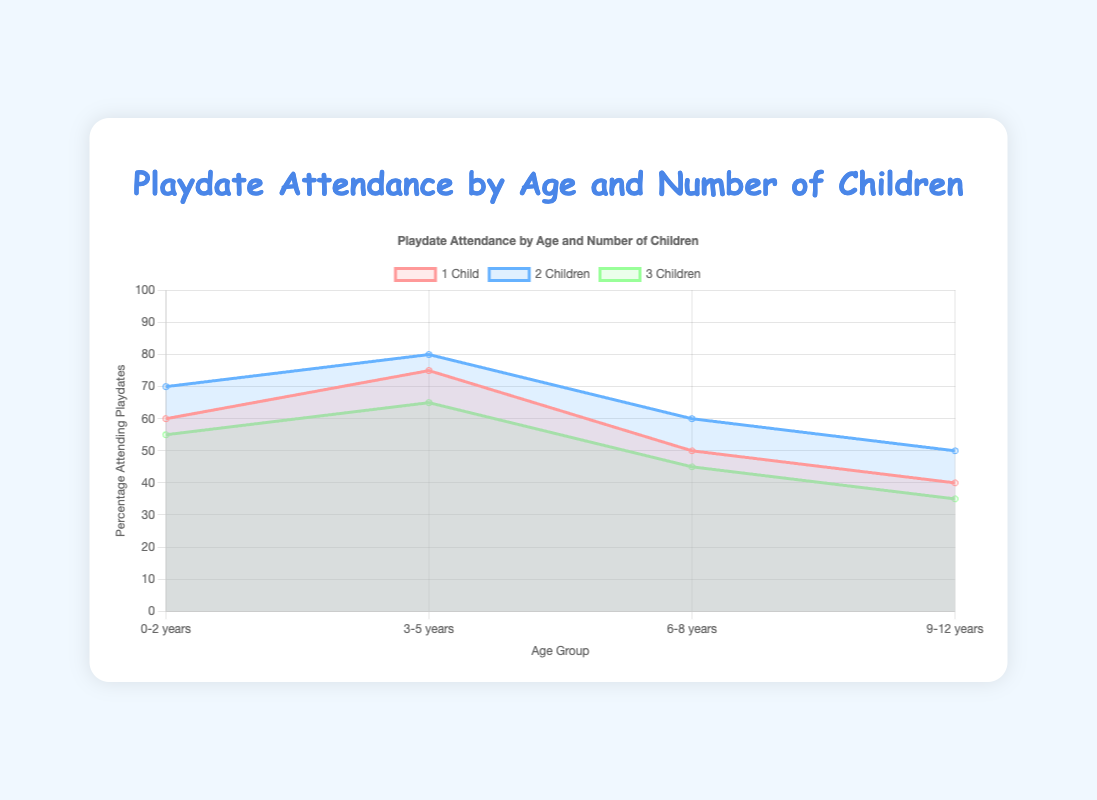What is the title of the chart? The title of the chart is displayed at the top and it is "Playdate Attendance by Age and Number of Children".
Answer: Playdate Attendance by Age and Number of Children Which age group has the highest percentage of families with 2 children attending playdates? Look for the line on the chart representing '2 Children', then identify the age group with the highest point on this line. The highest point is at "3-5 years."
Answer: 3-5 years Which group of children has the lowest percentage for the age group 6-8 years? Identify the age group 6-8 years on the x-axis and compare the percentage points for each number of children. The lowest value among them is for 3 children.
Answer: 3 children What is the overall trend in attendance as the age group increases from 0-12 years? Observe the general movement of the lines across the age groups from 0-12 years. The trend shows that playdate attendance generally decreases as the age group increases.
Answer: Decreases How much higher is the playdate attendance for families with 1 child in the age group 3-5 years compared to the age group 9-12 years? Find the percentage points for 1 child in both 3-5 years and 9-12 years age groups. The percentages are 75% and 40% respectively. Subtract the latter from the former: 75% - 40% = 35%.
Answer: 35% What is the percentage difference between families with 1 child and families with 2 children in the age group 0-2 years? Locate the points for 1 child and 2 children in the age group 0-2 years. The percentages are 60% for 1 child and 70% for 2 children. Subtract the percentages: 70% - 60% = 10%.
Answer: 10% Is the percentage of families with 3 children attending playdates ever higher than the percentage of families with 1 child? Compare the lines for '3 Children' and '1 Child' across all age groups. There is no point where the '3 Children' line is higher than the '1 Child' line.
Answer: No What can you infer about families with multiple children and playdate attendance? Examine the general levels of playdate attendance for different numbers of children across all age groups. Families with 2 children tend to have the highest attendance, followed by families with 1 child, and finally, families with 3 children tend to have the lowest attendance.
Answer: Families with 2 children have the highest attendance, followed by families with 1 child, and families with 3 children have the lowest What is the average percentage of families attending playdates for the age group 3-5 years? Add the percentages for 1, 2, and 3 children in the 3-5 years age group: 75% + 80% + 65% = 220%. Divide by 3 to find the average: 220% / 3 = ~73.3%.
Answer: ~73.3% Which age group shows the most significant drop in playdate attendance from 1 child to 3 children? Compare the differences between percentages of 1 and 3 children for each age group. For age 6-8 years, the drop is 50% for 1 child to 45% for 3 children, a 5% drop. For age 3-5 years, it’s 75% to 65%, a 10% drop. For age 0-2 years, it’s 60% to 55%, a 5% drop. For age 9-12 years, it’s 40% to 35%, a 5% drop. The most significant drop is in the 3-5 years age group with a 10% decrease.
Answer: 3-5 years 